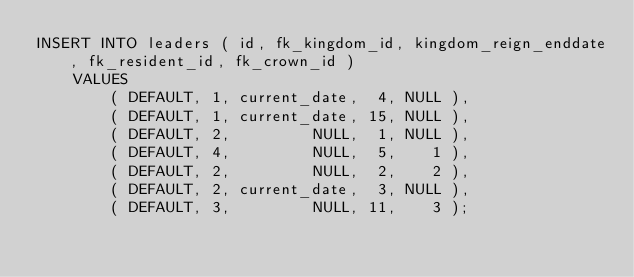Convert code to text. <code><loc_0><loc_0><loc_500><loc_500><_SQL_>INSERT INTO leaders ( id, fk_kingdom_id, kingdom_reign_enddate, fk_resident_id, fk_crown_id )
    VALUES
        ( DEFAULT, 1, current_date,  4, NULL ),
	    ( DEFAULT, 1, current_date, 15, NULL ),
        ( DEFAULT, 2,         NULL,  1, NULL ),
        ( DEFAULT, 4,         NULL,  5,    1 ),
        ( DEFAULT, 2,         NULL,  2,    2 ),
        ( DEFAULT, 2, current_date,  3, NULL ),
        ( DEFAULT, 3,         NULL, 11,    3 );
</code> 